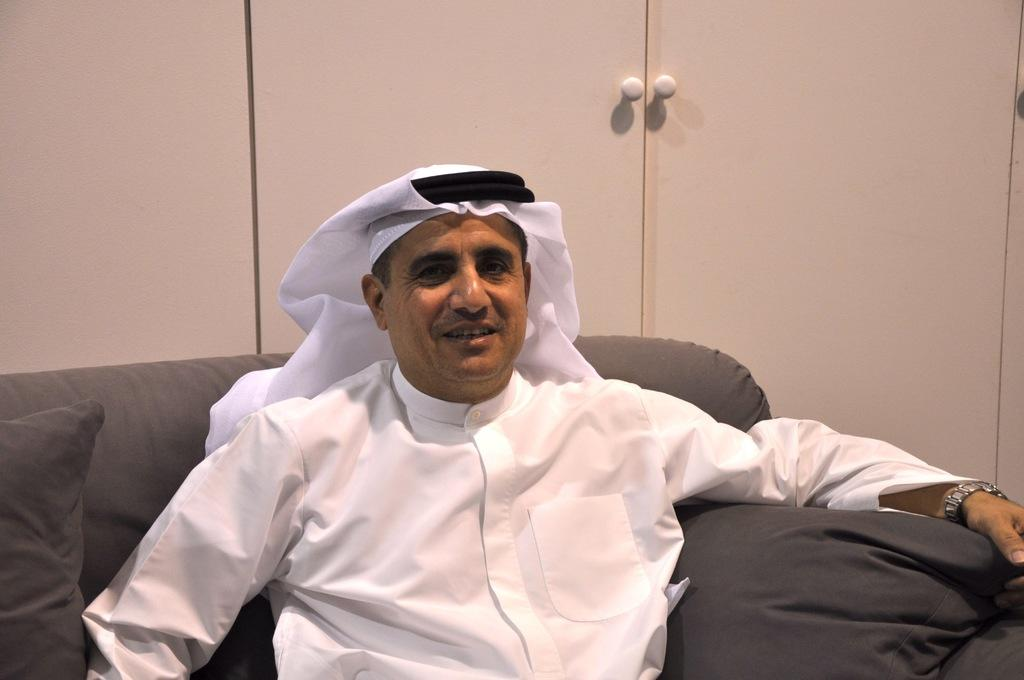What is the person in the image doing? The person is sitting on a couch in the image. What is the person's facial expression? The person is smiling. What can be seen behind the couch in the image? There is a cupboard visible behind the couch. How many boys are sitting on the couch in the image? There is no mention of boys in the image; it only shows a person sitting on the couch. What flavor of ice cream is the person holding in the image? There is no ice cream present in the image. 